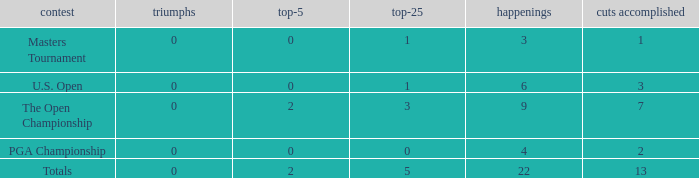What is the average number of cuts made for events with under 4 entries and more than 0 wins? None. 